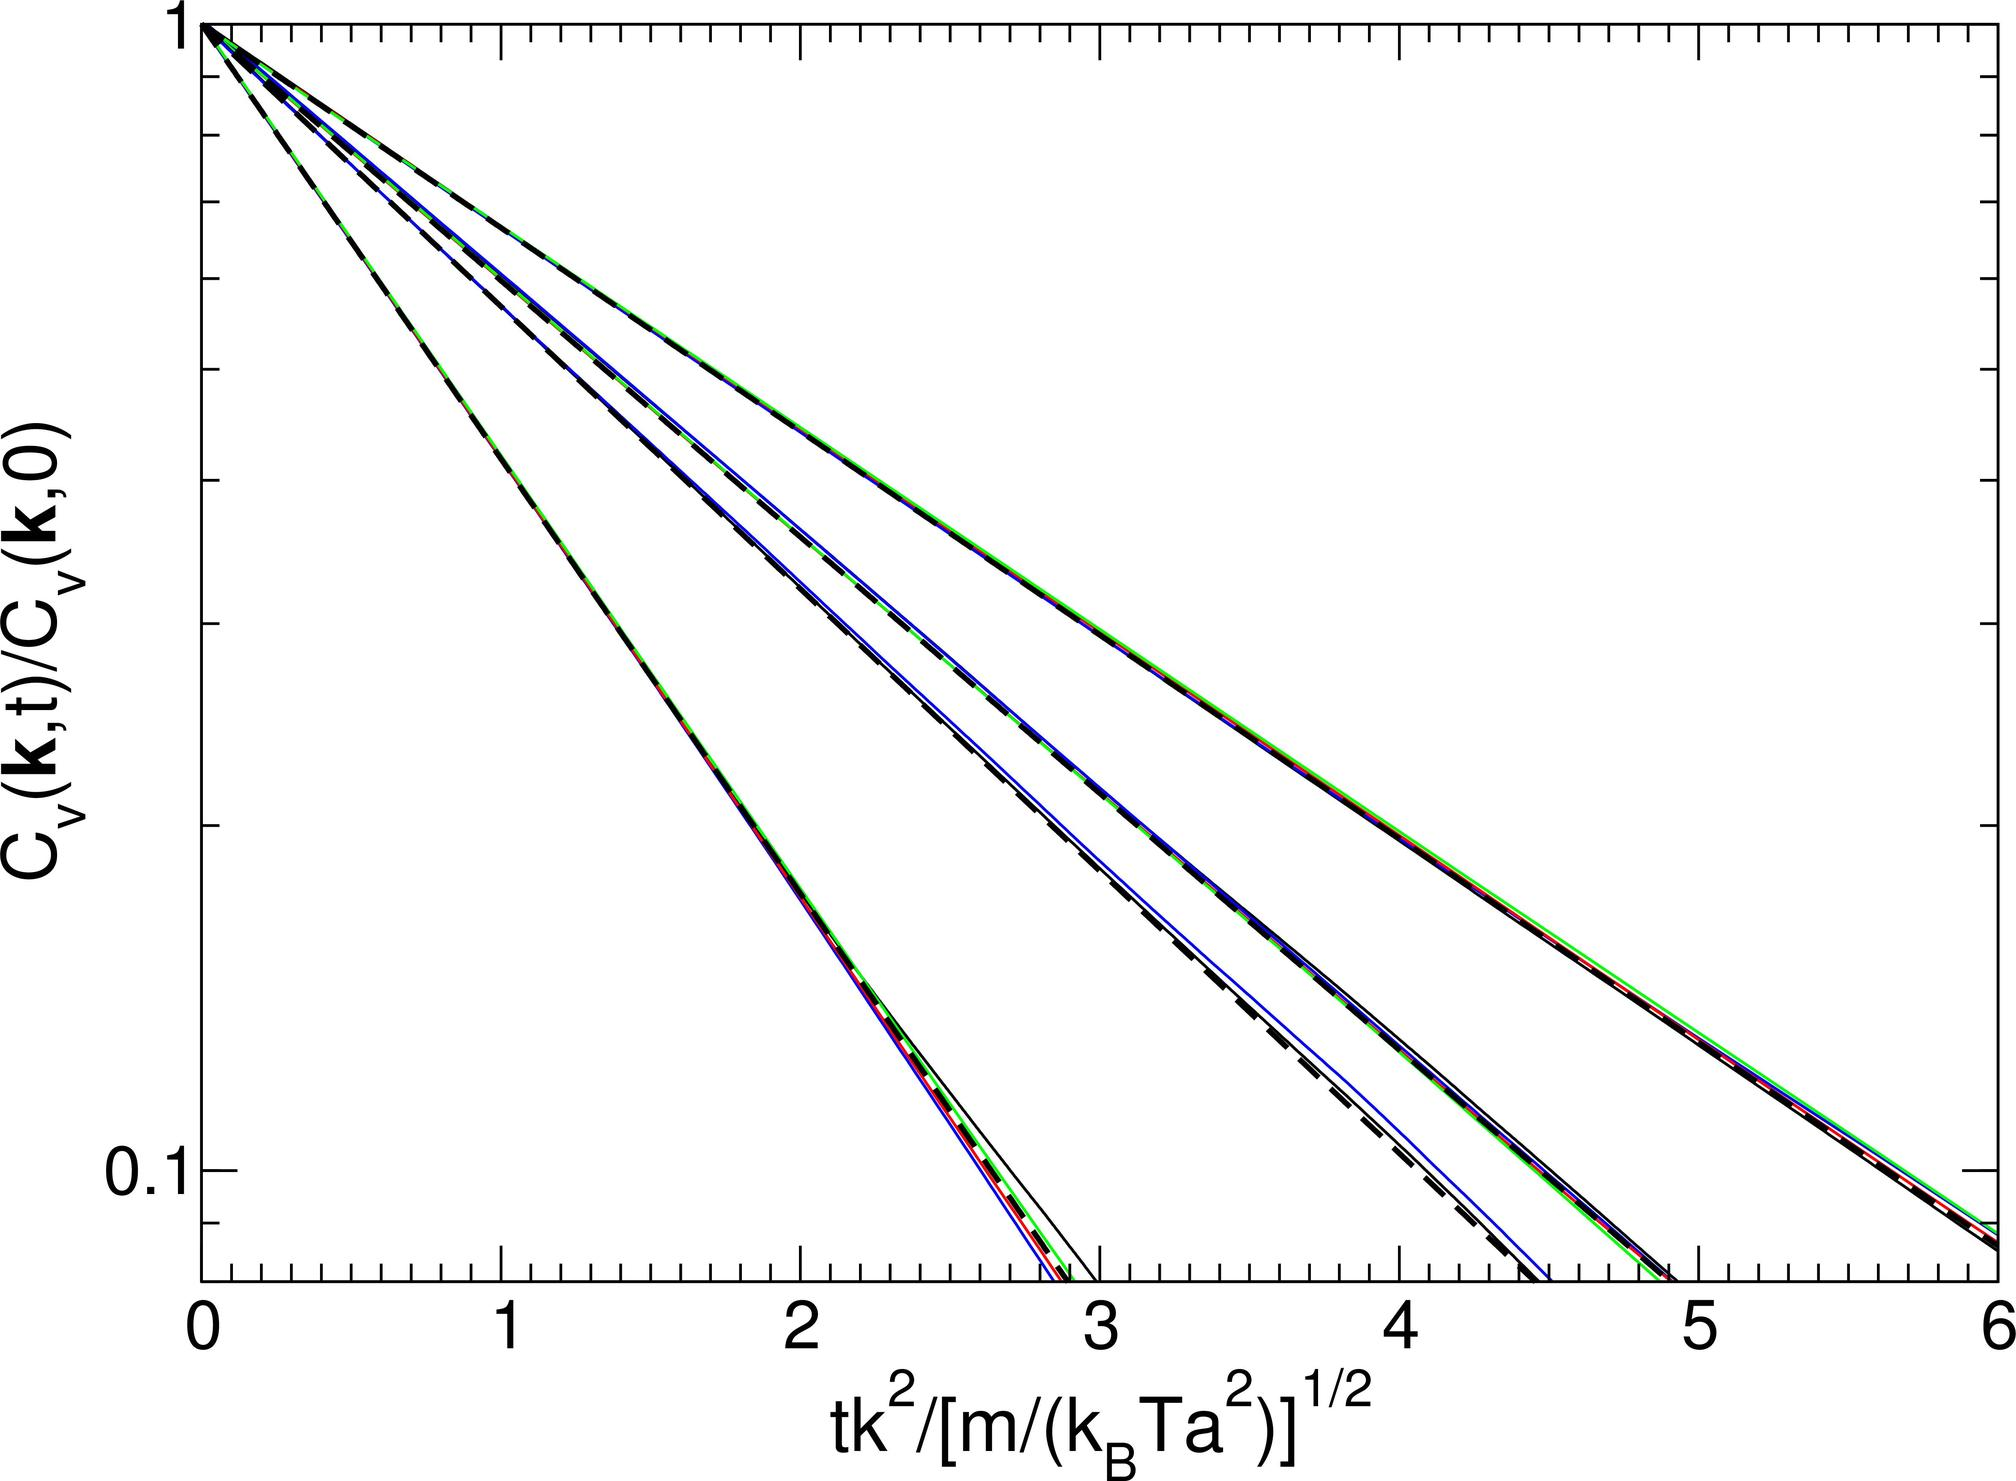What role does the parameter \( t \) play in shaping the curves shown in the graph? The parameter \( t \) significantly influences the progression of the curves over the x-axis range. It directly scales with \( K^2 \) in the numerator of the x-axis expression, meaning that an increase in \( t \) intensifies the value needed to shift across the x-axis, essentially stretching the curves horizontally across the graph. As \( t \) increases, each curve will require more substantial movement in terms of \( tK^2 \) to advance to higher x-axis positions, resulting in a more elongated and less steep appearance. 